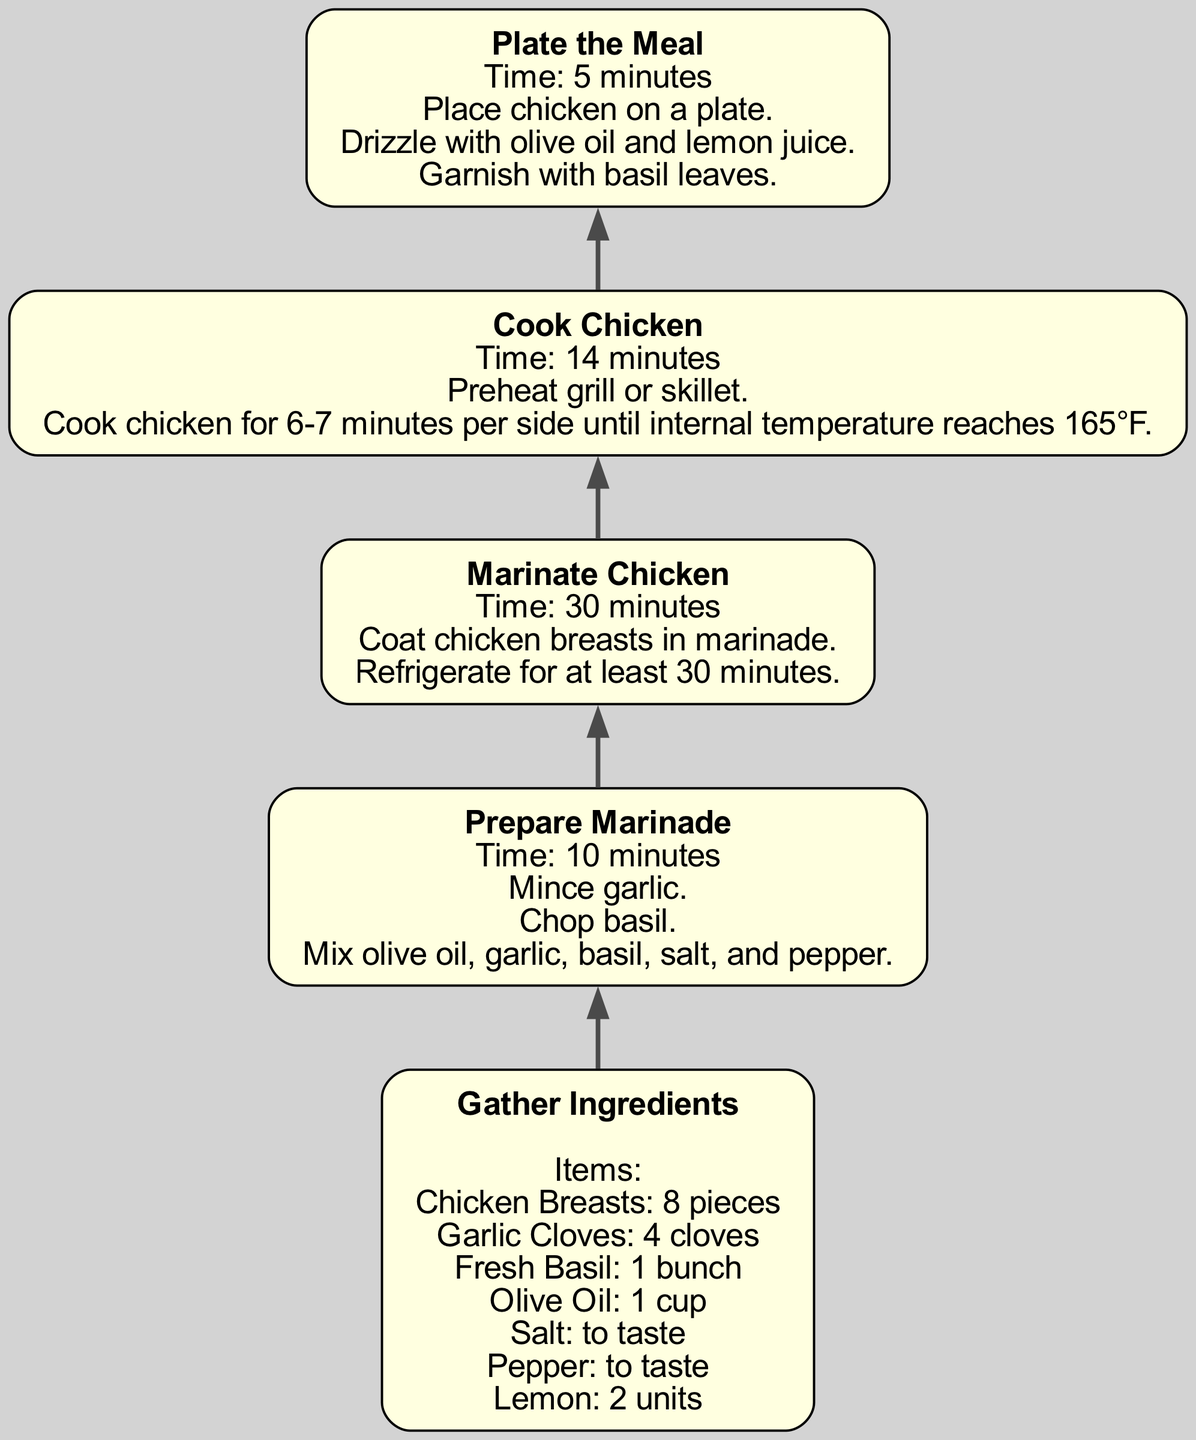What is the first step in the meal preparation process? The first step listed in the diagram is "Gather Ingredients." This is clearly outlined as the initial action required to begin the meal preparation.
Answer: Gather Ingredients How many cloves of garlic are needed? The diagram specifies that 4 cloves of garlic are required as part of the ingredients. This is noted directly under the "Gather Ingredients" step.
Answer: 4 cloves What is the total cooking time for the chicken? The cooking time for the chicken, according to the diagram, is 14 minutes. This duration is stated under the "Cook Chicken" step.
Answer: 14 minutes Which step follows "Prepare Marinade"? The next step after "Prepare Marinade" is "Marinate Chicken," according to the sequential flow indicated in the diagram between nodes.
Answer: Marinate Chicken How long should the chicken be refrigerated during marination? The diagram indicates that the chicken should be refrigerated for at least 30 minutes during the "Marinate Chicken" step.
Answer: 30 minutes What garnishing is suggested for the plated meal? The diagram specifies "garnish with basil leaves" as part of the plating instructions under the "Plate the Meal" step.
Answer: Basil leaves What do you do before cooking the chicken? Prior to cooking the chicken, the step mentions to "Preheat grill or skillet," which is necessary to prepare the cooking surface.
Answer: Preheat grill or skillet Which ingredient is suggested to drizzle over the chicken when plating? The diagram indicates to "drizzle with olive oil and lemon juice" as part of the plating instructions, highlighting these as key finishing touches.
Answer: Olive oil and lemon juice What is the total number of steps in the meal preparation process? The diagram outlines a total of 5 distinct steps in the meal preparation process, structured sequentially from gathering ingredients to plating.
Answer: 5 steps 